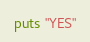<code> <loc_0><loc_0><loc_500><loc_500><_Ruby_>puts "YES"</code> 